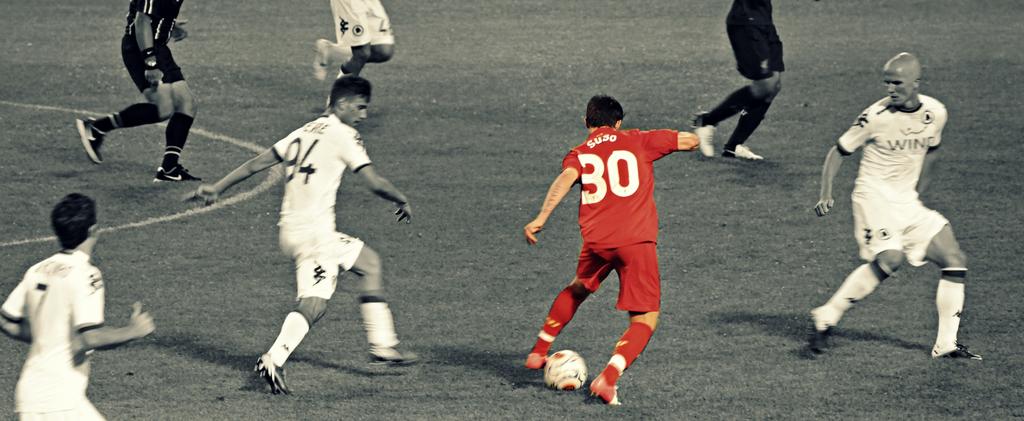What is the plater in red's number?
Offer a very short reply. 30. 